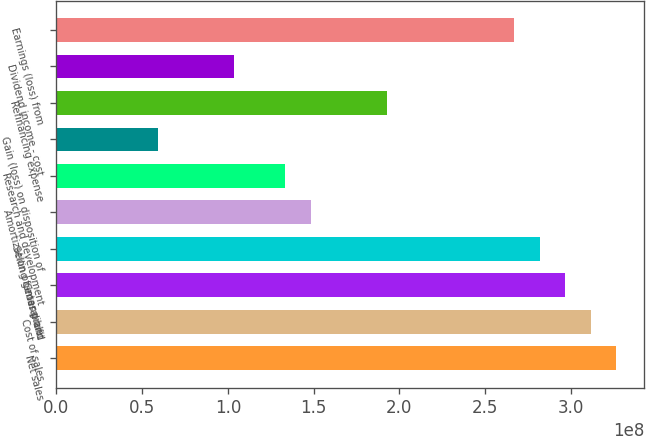Convert chart. <chart><loc_0><loc_0><loc_500><loc_500><bar_chart><fcel>Net sales<fcel>Cost of sales<fcel>Gross profit<fcel>Selling general and<fcel>Amortization of intangible<fcel>Research and development<fcel>Gain (loss) on disposition of<fcel>Refinancing expense<fcel>Dividend income - cost<fcel>Earnings (loss) from<nl><fcel>3.26371e+08<fcel>3.11536e+08<fcel>2.96701e+08<fcel>2.81866e+08<fcel>1.4835e+08<fcel>1.33515e+08<fcel>5.93401e+07<fcel>1.92855e+08<fcel>1.03845e+08<fcel>2.6703e+08<nl></chart> 